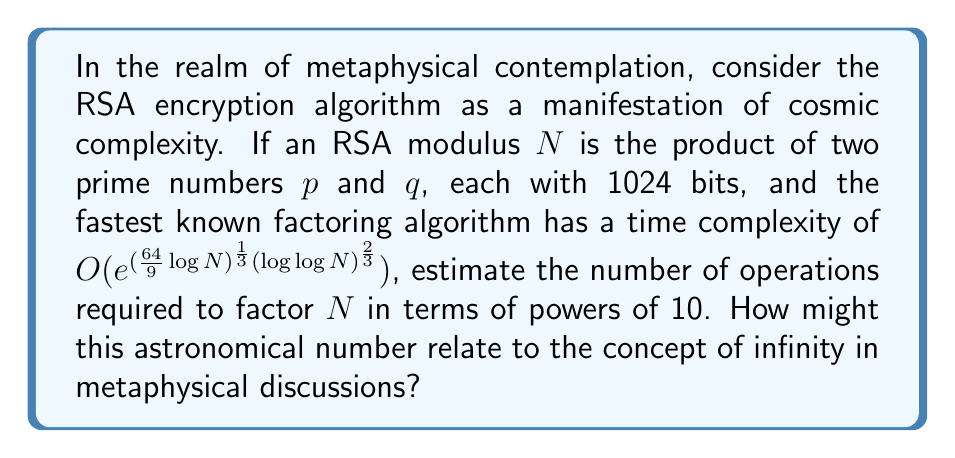Teach me how to tackle this problem. Let's approach this step-by-step:

1) The RSA modulus $N$ is 1024 * 2 = 2048 bits long.

2) We need to calculate $(\frac{64}{9}\log N)^{\frac{1}{3}}(\log \log N)^{\frac{2}{3}}$

3) First, $\log N \approx 2048 \log 2 \approx 1419.2$ (using natural logarithm)

4) $\log \log N \approx \log 1419.2 \approx 7.26$

5) Now, let's calculate:
   $$(\frac{64}{9} * 1419.2)^{\frac{1}{3}} * (7.26)^{\frac{2}{3}} \approx 13.8$$

6) The number of operations is proportional to $e^{13.8} \approx 9.8 * 10^5$

7) This is just the exponent in the time complexity. The actual number of operations is approximately $10^{980000}$

8) To put this in perspective, the number of atoms in the observable universe is estimated to be around $10^{80}$

9) The concept of such an enormous number, while finite, approaches the metaphysical notion of infinity in practical terms. It's so large that it transcends human comprehension, much like the concept of infinity in metaphysical discussions.
Answer: $10^{980000}$ operations, approaching metaphysical infinity 